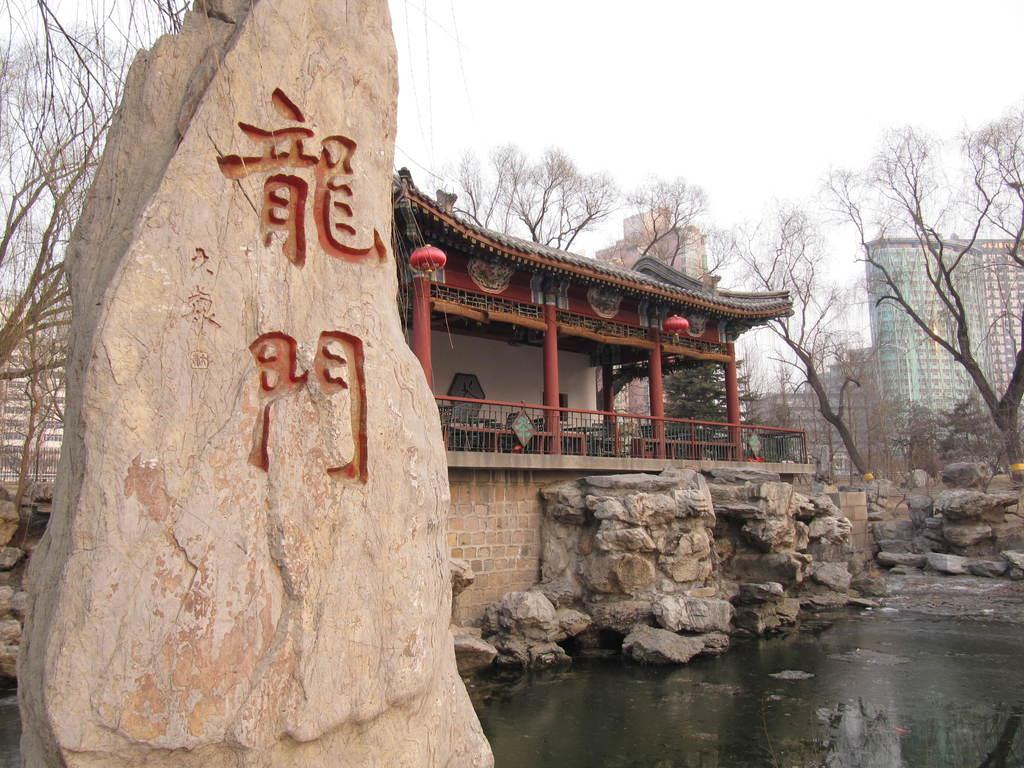What type of architecture is featured in the image? There is Chinese architecture in the image. What can be observed about the vegetation in the image? There are many dry trees in the image. What is visible in the background on the right side of the image? There is a tall building in the background on the right side of the image. How many seeds are visible on the ground in the image? There are no seeds visible on the ground in the image. What type of bead is being used as a decoration on the Chinese architecture? There is no mention of beads being used as decoration on the Chinese architecture in the image. 